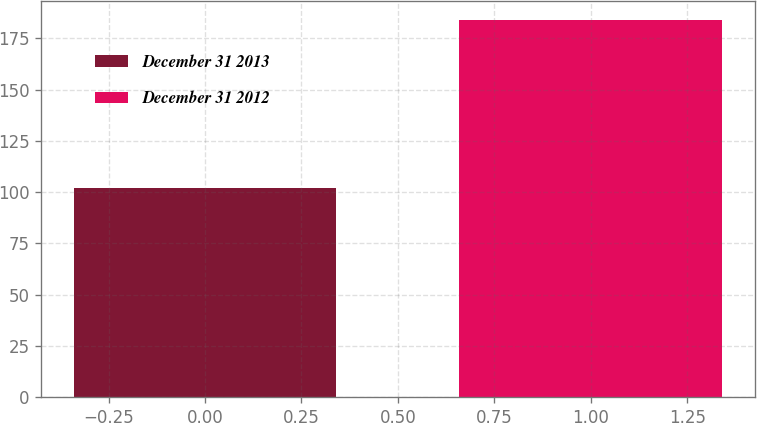<chart> <loc_0><loc_0><loc_500><loc_500><bar_chart><fcel>December 31 2013<fcel>December 31 2012<nl><fcel>102.2<fcel>183.9<nl></chart> 